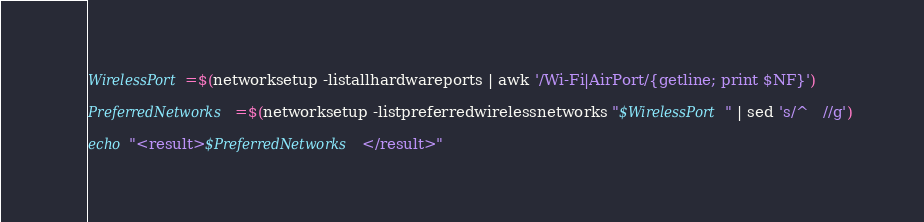Convert code to text. <code><loc_0><loc_0><loc_500><loc_500><_Bash_>
WirelessPort=$(networksetup -listallhardwareports | awk '/Wi-Fi|AirPort/{getline; print $NF}')

PreferredNetworks=$(networksetup -listpreferredwirelessnetworks "$WirelessPort" | sed 's/^   //g')

echo "<result>$PreferredNetworks</result>"</code> 